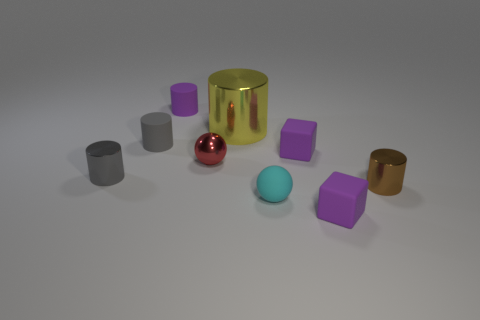There is a gray thing in front of the tiny metal sphere; what shape is it?
Ensure brevity in your answer.  Cylinder. How many other tiny things have the same material as the cyan object?
Provide a succinct answer. 4. There is a large yellow object; is its shape the same as the purple rubber thing that is in front of the brown thing?
Give a very brief answer. No. There is a matte block in front of the small brown shiny object in front of the small gray metallic object; are there any yellow shiny cylinders left of it?
Your answer should be very brief. Yes. There is a matte block that is in front of the small brown metal cylinder; what is its size?
Make the answer very short. Small. What is the material of the cyan sphere that is the same size as the brown object?
Your answer should be very brief. Rubber. Does the big yellow object have the same shape as the small red thing?
Keep it short and to the point. No. How many things are either green objects or tiny rubber objects that are on the left side of the big yellow object?
Your response must be concise. 2. Does the purple rubber object in front of the cyan thing have the same size as the big yellow metallic cylinder?
Ensure brevity in your answer.  No. What number of tiny matte things are left of the metal object behind the gray thing on the right side of the tiny gray metal cylinder?
Give a very brief answer. 2. 